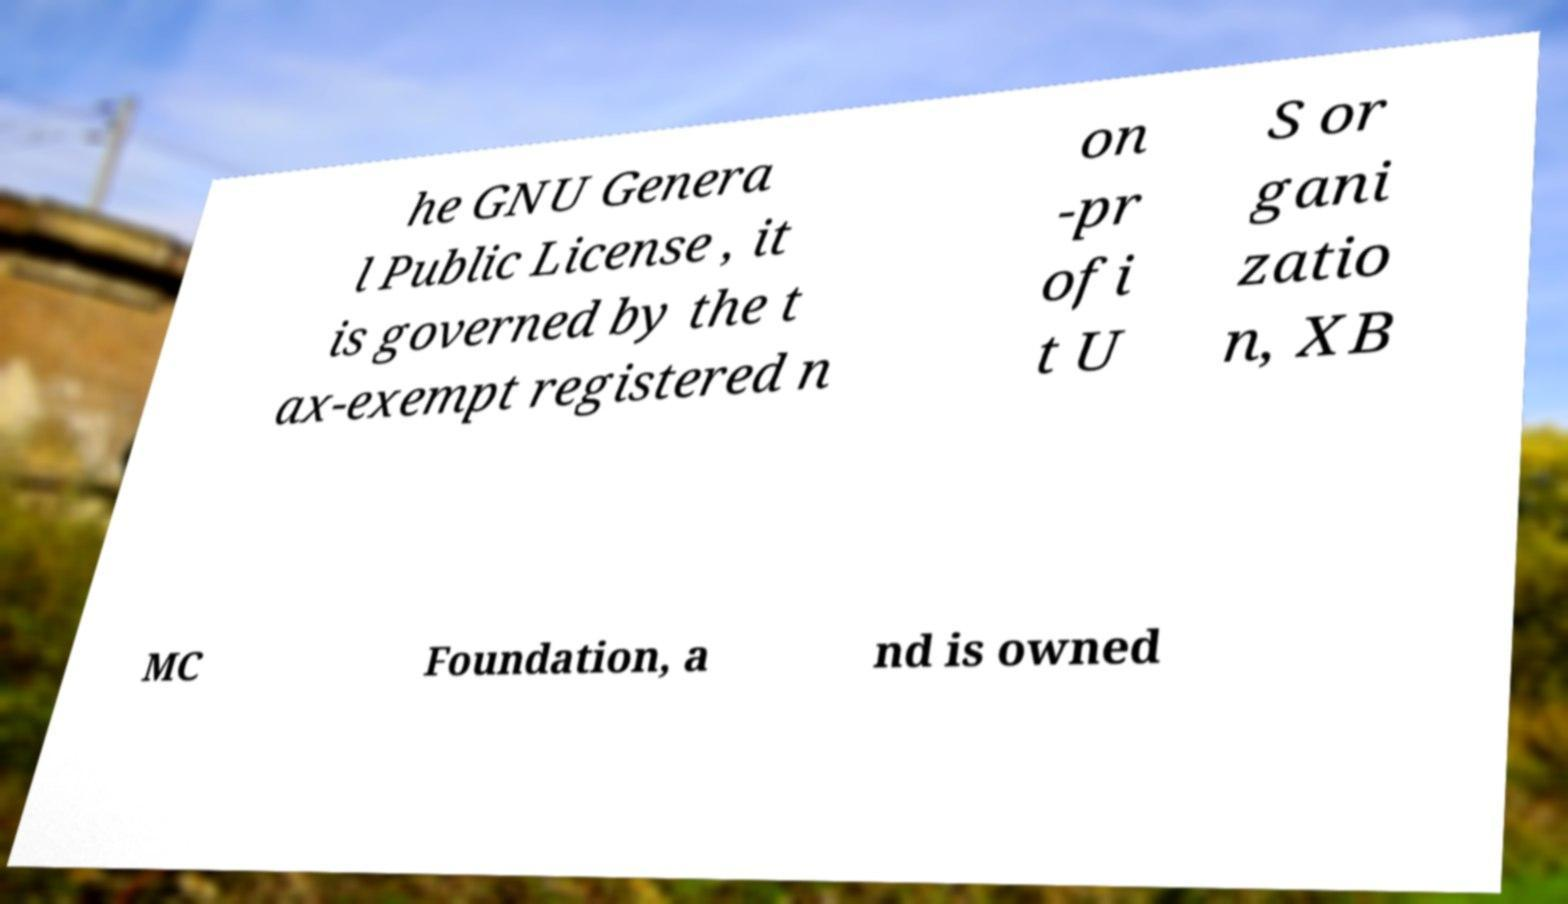Can you read and provide the text displayed in the image?This photo seems to have some interesting text. Can you extract and type it out for me? he GNU Genera l Public License , it is governed by the t ax-exempt registered n on -pr ofi t U S or gani zatio n, XB MC Foundation, a nd is owned 